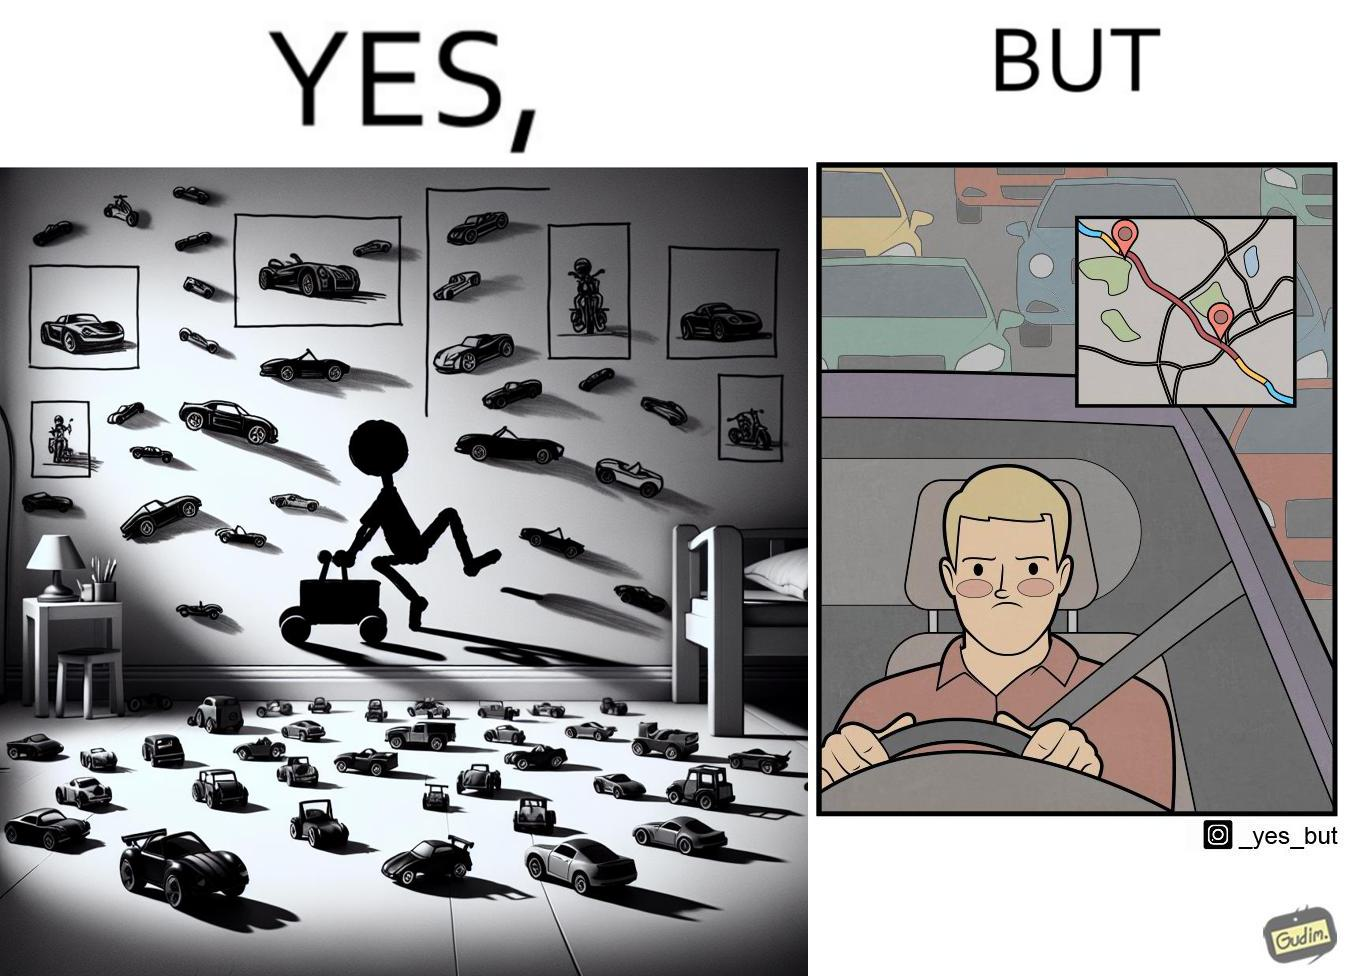Is there satirical content in this image? Yes, this image is satirical. 